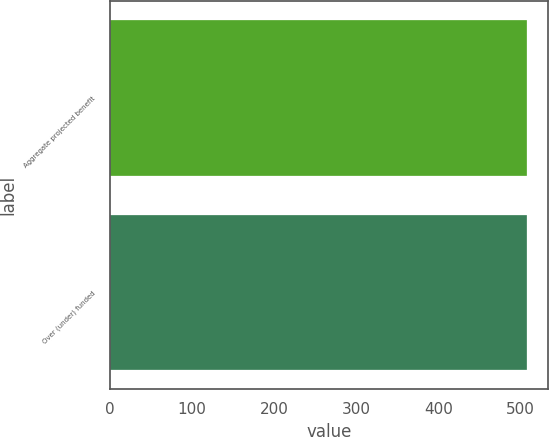Convert chart. <chart><loc_0><loc_0><loc_500><loc_500><bar_chart><fcel>Aggregate projected benefit<fcel>Over (under) funded<nl><fcel>508<fcel>508.1<nl></chart> 